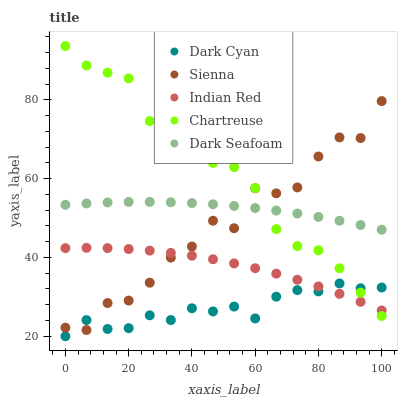Does Dark Cyan have the minimum area under the curve?
Answer yes or no. Yes. Does Chartreuse have the maximum area under the curve?
Answer yes or no. Yes. Does Sienna have the minimum area under the curve?
Answer yes or no. No. Does Sienna have the maximum area under the curve?
Answer yes or no. No. Is Dark Seafoam the smoothest?
Answer yes or no. Yes. Is Sienna the roughest?
Answer yes or no. Yes. Is Chartreuse the smoothest?
Answer yes or no. No. Is Chartreuse the roughest?
Answer yes or no. No. Does Dark Cyan have the lowest value?
Answer yes or no. Yes. Does Sienna have the lowest value?
Answer yes or no. No. Does Chartreuse have the highest value?
Answer yes or no. Yes. Does Sienna have the highest value?
Answer yes or no. No. Is Dark Cyan less than Dark Seafoam?
Answer yes or no. Yes. Is Dark Seafoam greater than Dark Cyan?
Answer yes or no. Yes. Does Indian Red intersect Dark Cyan?
Answer yes or no. Yes. Is Indian Red less than Dark Cyan?
Answer yes or no. No. Is Indian Red greater than Dark Cyan?
Answer yes or no. No. Does Dark Cyan intersect Dark Seafoam?
Answer yes or no. No. 